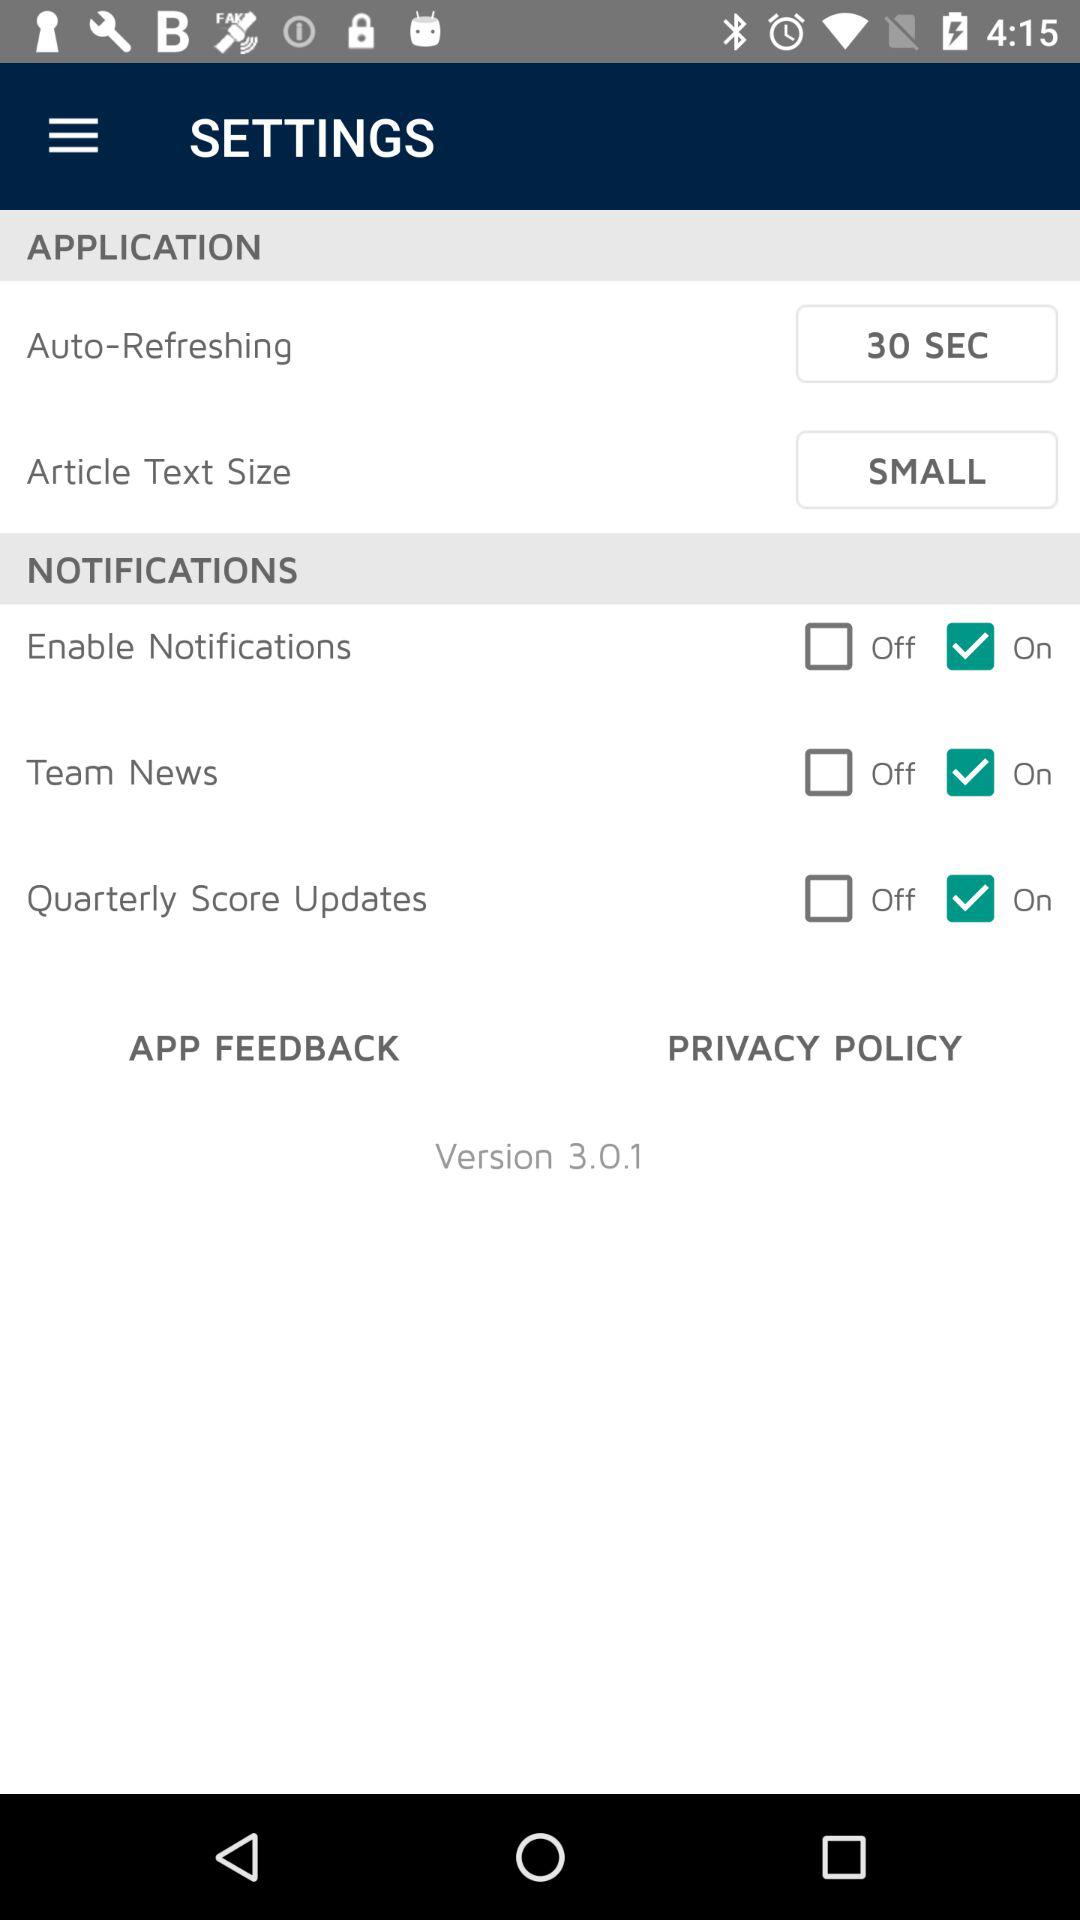Is the "Quarterly Score Updates" option on or off? The "Quarterly Score Updates" option is "on". 